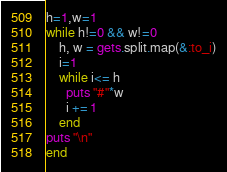Convert code to text. <code><loc_0><loc_0><loc_500><loc_500><_Ruby_>h=1,w=1
while h!=0 && w!=0
    h, w = gets.split.map(&:to_i)
    i=1
    while i<= h
      puts "#"*w
      i += 1
    end
puts "\n"
end</code> 